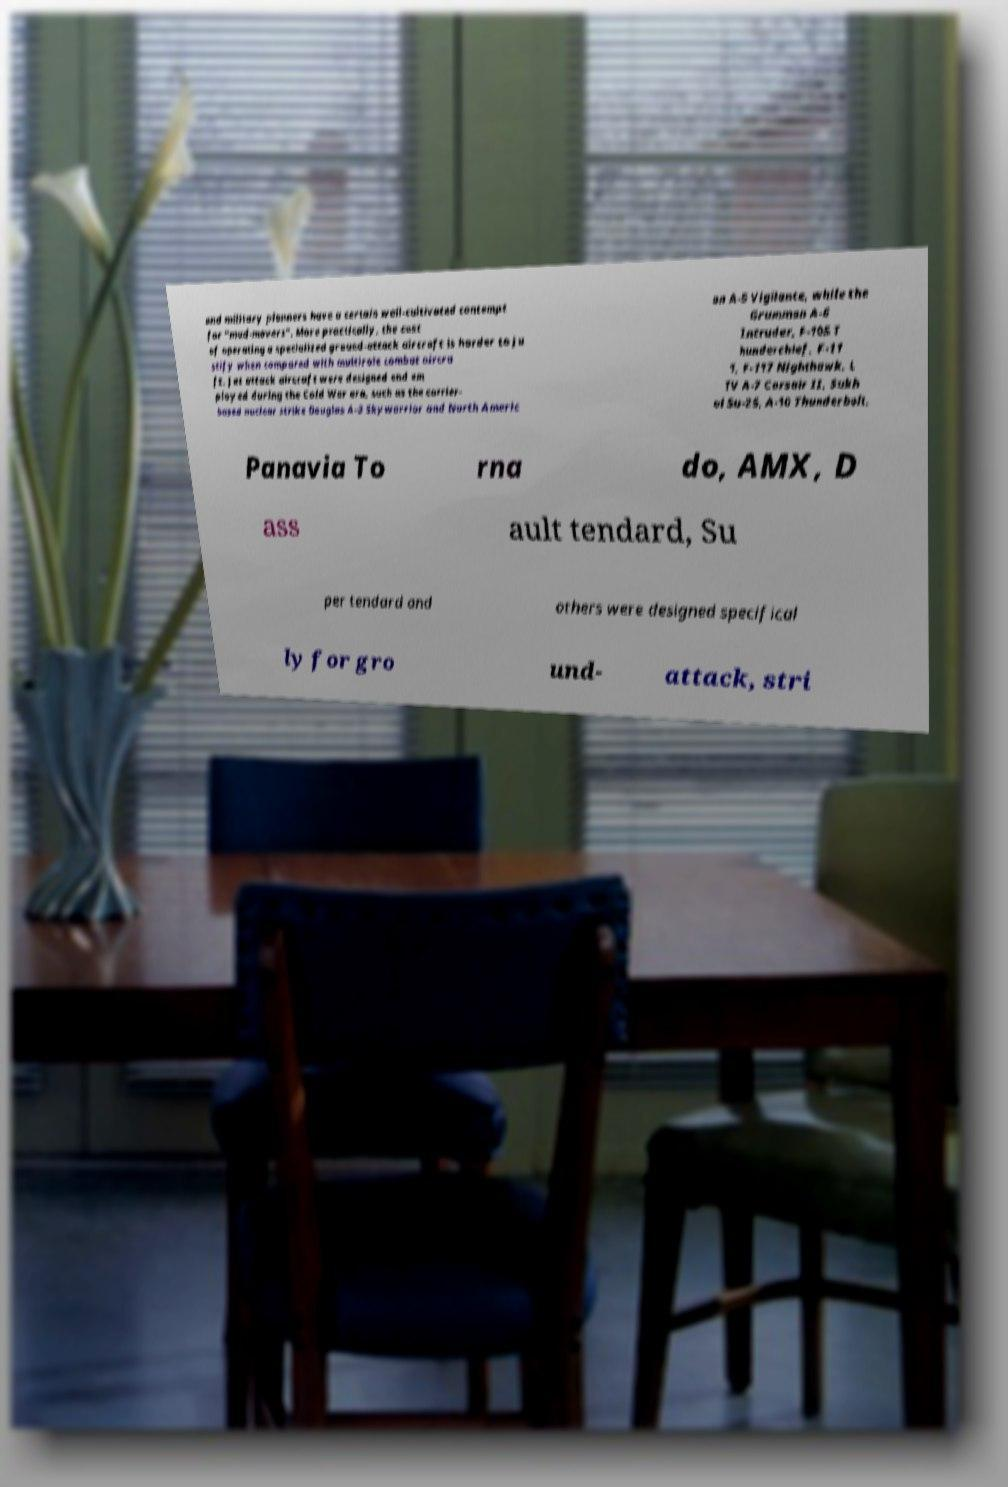Can you read and provide the text displayed in the image?This photo seems to have some interesting text. Can you extract and type it out for me? and military planners have a certain well-cultivated contempt for "mud-movers". More practically, the cost of operating a specialized ground-attack aircraft is harder to ju stify when compared with multirole combat aircra ft. Jet attack aircraft were designed and em ployed during the Cold War era, such as the carrier- based nuclear strike Douglas A-3 Skywarrior and North Americ an A-5 Vigilante, while the Grumman A-6 Intruder, F-105 T hunderchief, F-11 1, F-117 Nighthawk, L TV A-7 Corsair II, Sukh oi Su-25, A-10 Thunderbolt, Panavia To rna do, AMX, D ass ault tendard, Su per tendard and others were designed specifical ly for gro und- attack, stri 